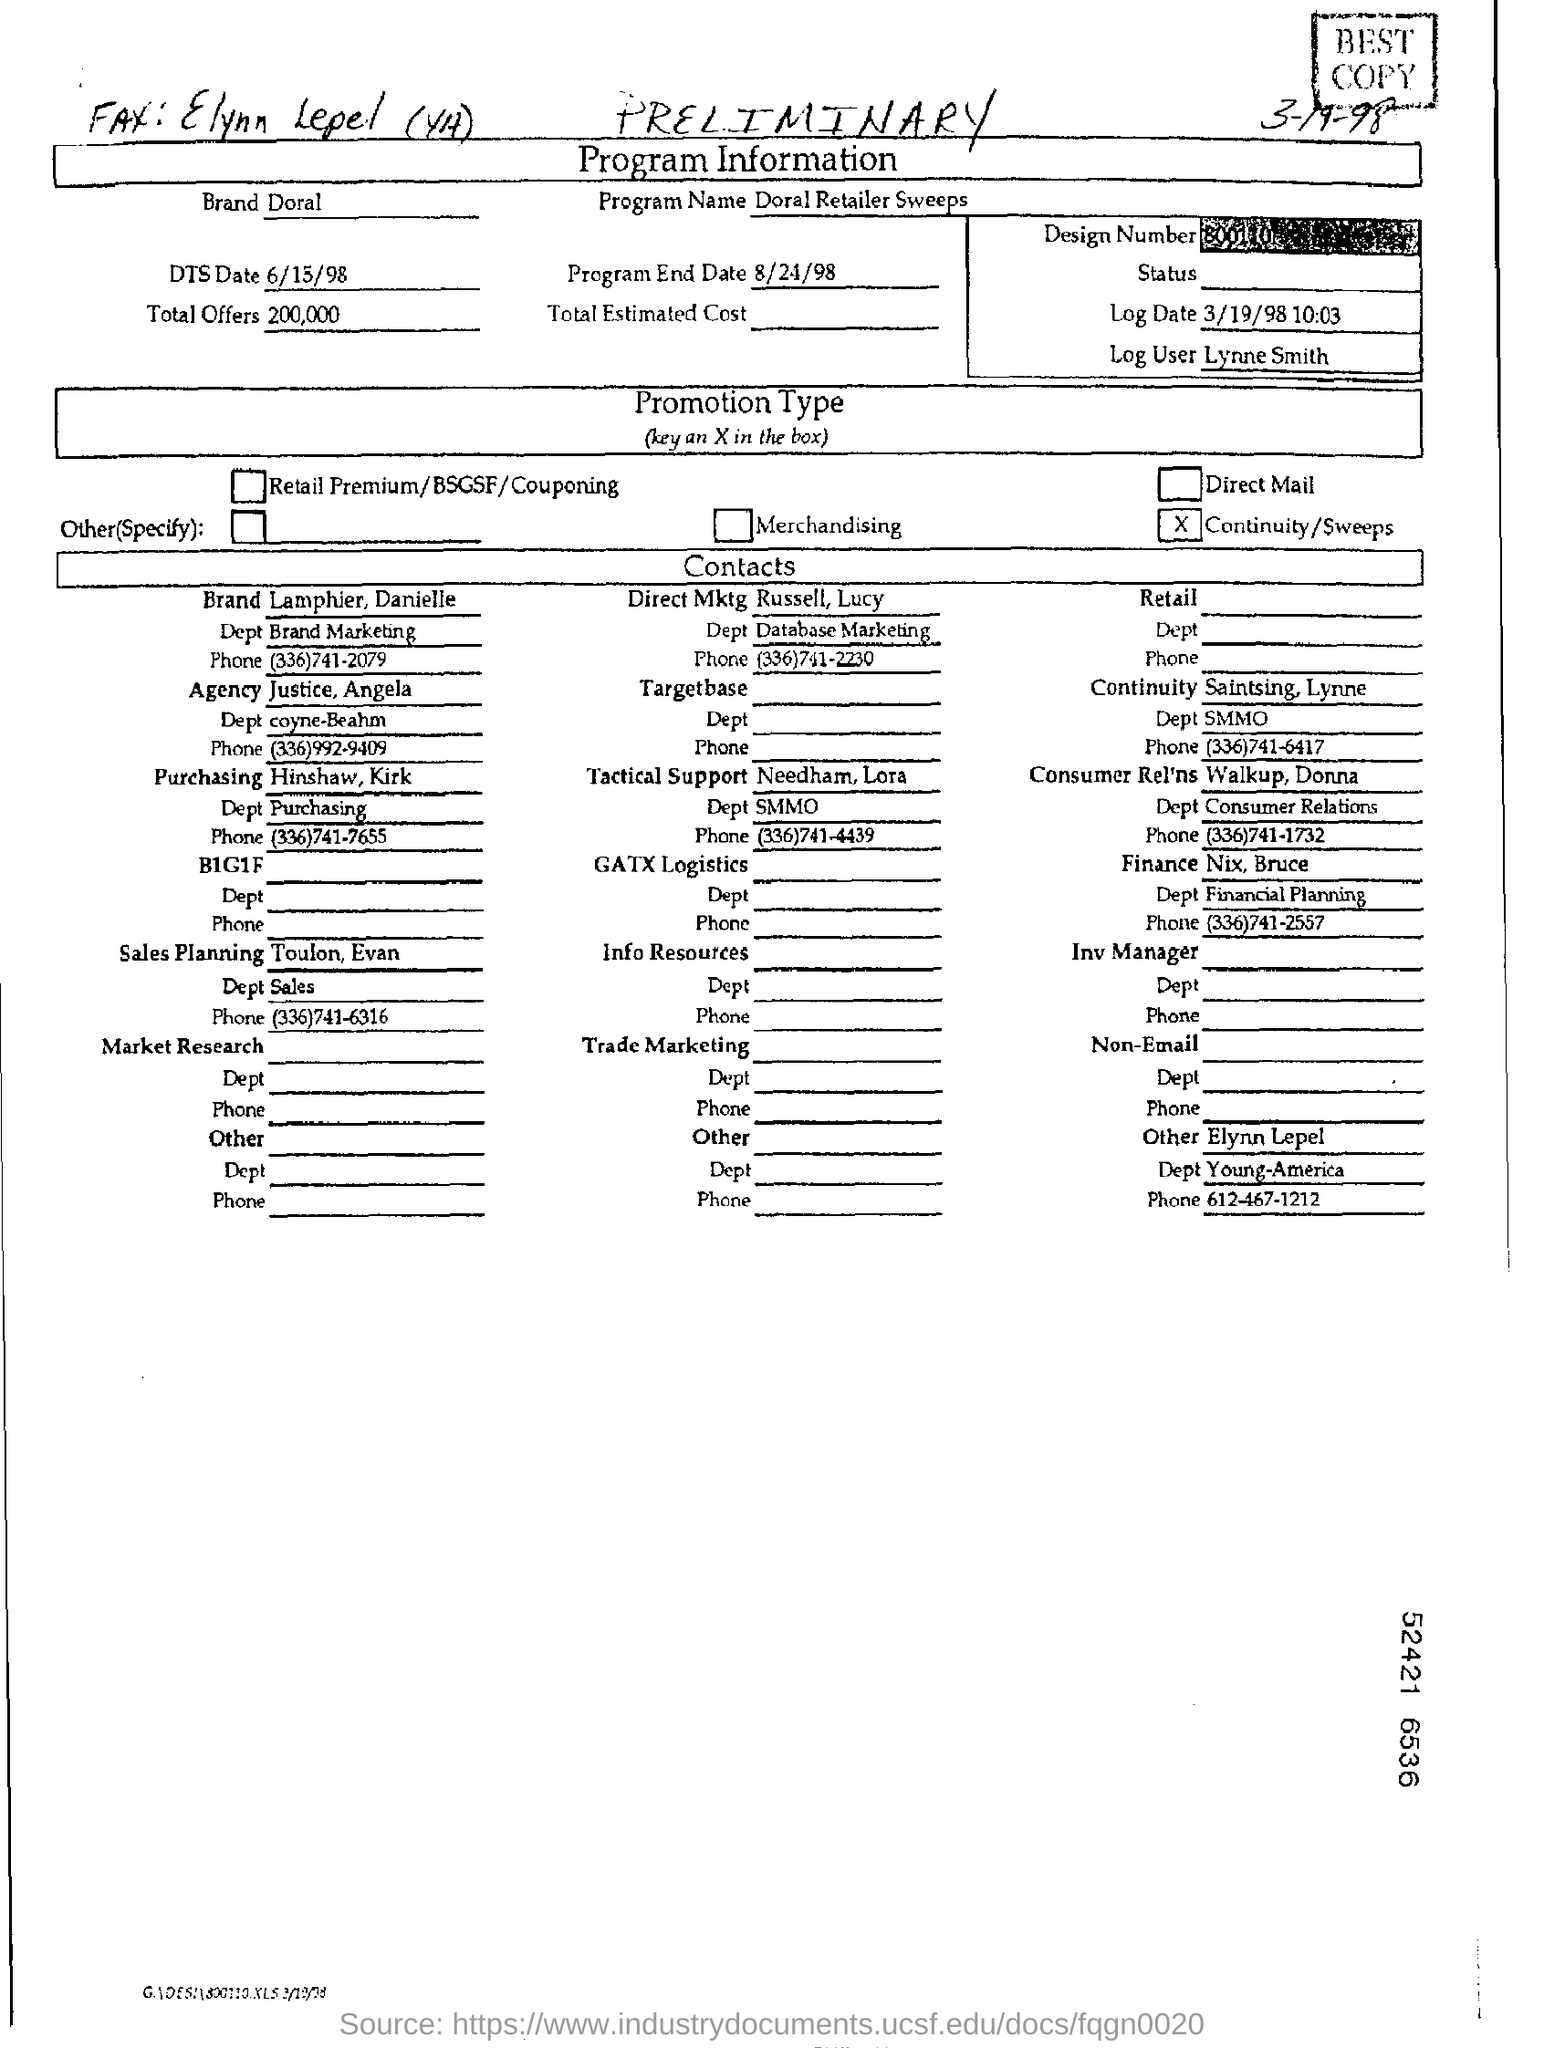What is the program name ?
Offer a very short reply. Doral retailer sweeps. How much is the total offers ?
Give a very brief answer. 200,000. Who is the log user ?
Provide a short and direct response. Lynne smith. 